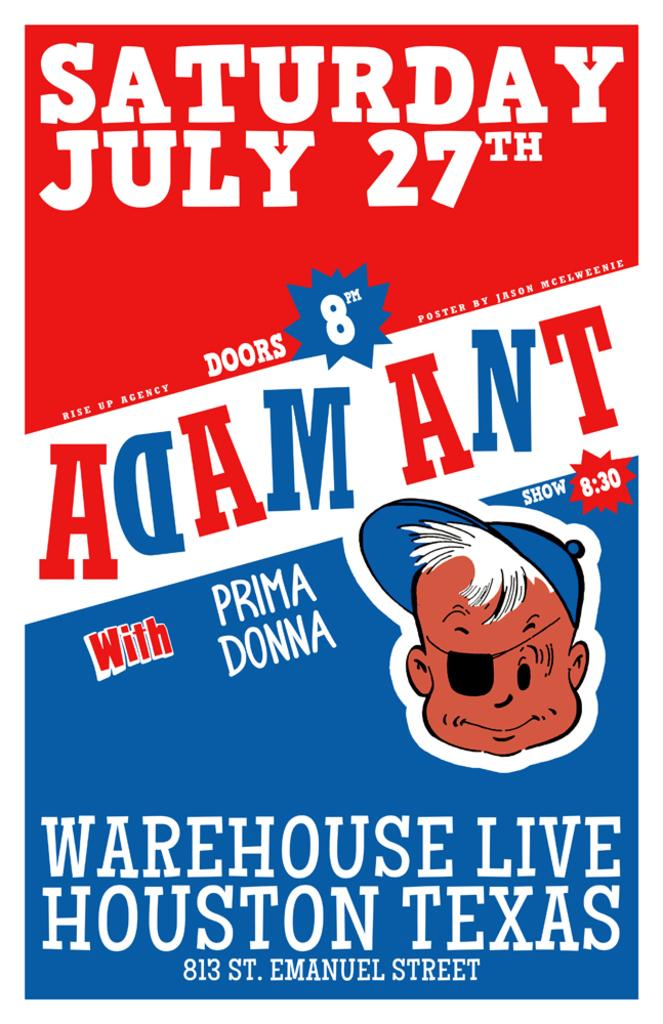What is the main subject in the image? There is a poster in the image. How many beasts are depicted on the poster in the image? There is no information about beasts or any other specific details on the poster, so it cannot be determined from the image. 